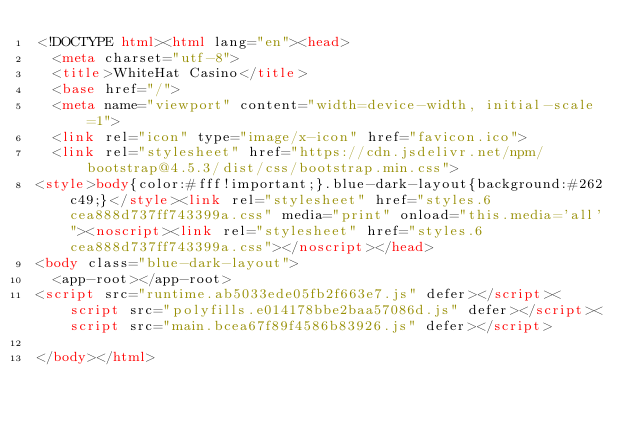<code> <loc_0><loc_0><loc_500><loc_500><_HTML_><!DOCTYPE html><html lang="en"><head>
  <meta charset="utf-8">
  <title>WhiteHat Casino</title>
  <base href="/">
  <meta name="viewport" content="width=device-width, initial-scale=1">
  <link rel="icon" type="image/x-icon" href="favicon.ico">
  <link rel="stylesheet" href="https://cdn.jsdelivr.net/npm/bootstrap@4.5.3/dist/css/bootstrap.min.css">
<style>body{color:#fff!important;}.blue-dark-layout{background:#262c49;}</style><link rel="stylesheet" href="styles.6cea888d737ff743399a.css" media="print" onload="this.media='all'"><noscript><link rel="stylesheet" href="styles.6cea888d737ff743399a.css"></noscript></head>
<body class="blue-dark-layout">
  <app-root></app-root>
<script src="runtime.ab5033ede05fb2f663e7.js" defer></script><script src="polyfills.e014178bbe2baa57086d.js" defer></script><script src="main.bcea67f89f4586b83926.js" defer></script>

</body></html></code> 